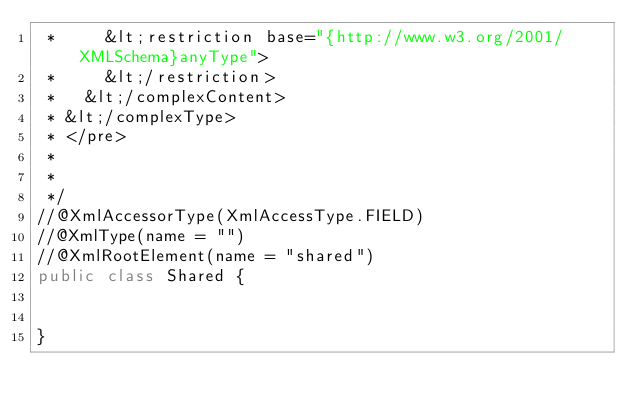<code> <loc_0><loc_0><loc_500><loc_500><_Java_> *     &lt;restriction base="{http://www.w3.org/2001/XMLSchema}anyType">
 *     &lt;/restriction>
 *   &lt;/complexContent>
 * &lt;/complexType>
 * </pre>
 * 
 * 
 */
//@XmlAccessorType(XmlAccessType.FIELD)
//@XmlType(name = "")
//@XmlRootElement(name = "shared")
public class Shared {


}
</code> 